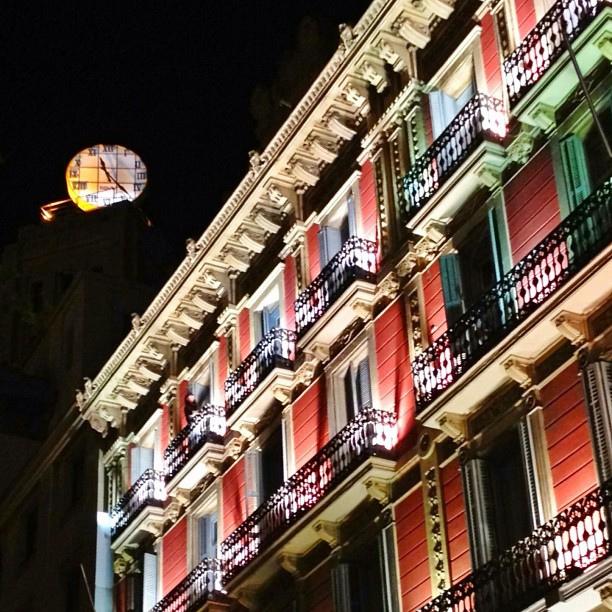Is the building well lit?
Give a very brief answer. Yes. Can you tell the time?
Be succinct. Yes. What is the color of the wall?
Write a very short answer. Red. 